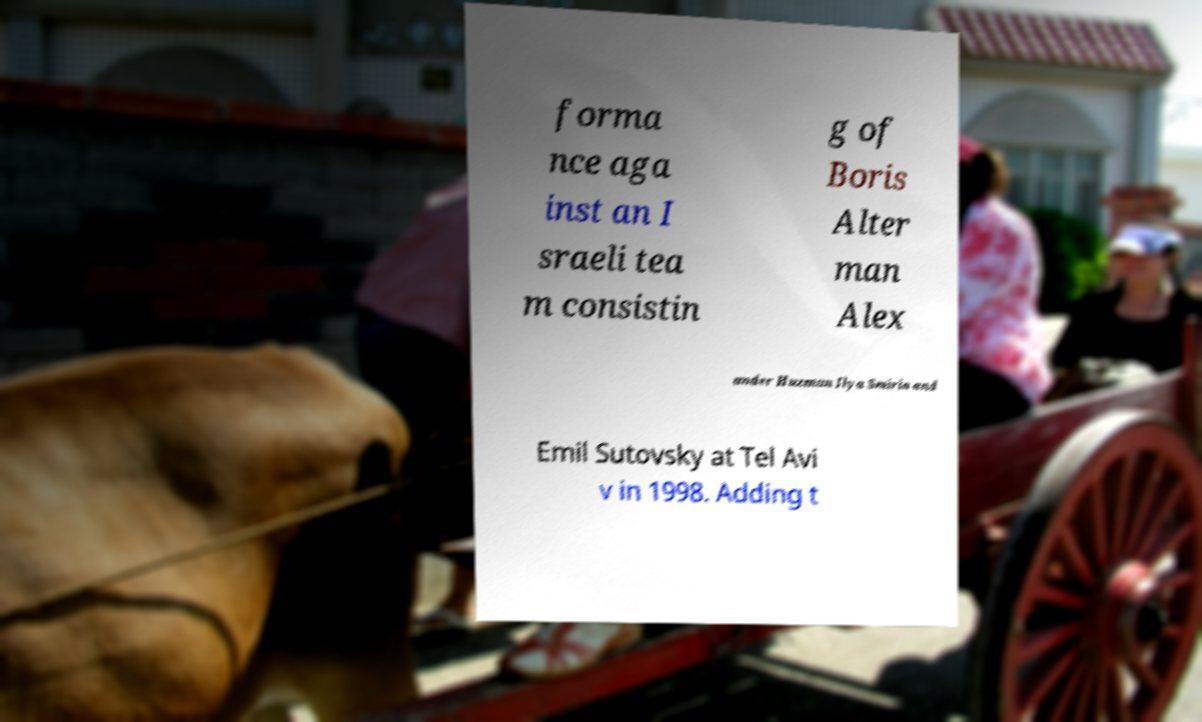Can you accurately transcribe the text from the provided image for me? forma nce aga inst an I sraeli tea m consistin g of Boris Alter man Alex ander Huzman Ilya Smirin and Emil Sutovsky at Tel Avi v in 1998. Adding t 